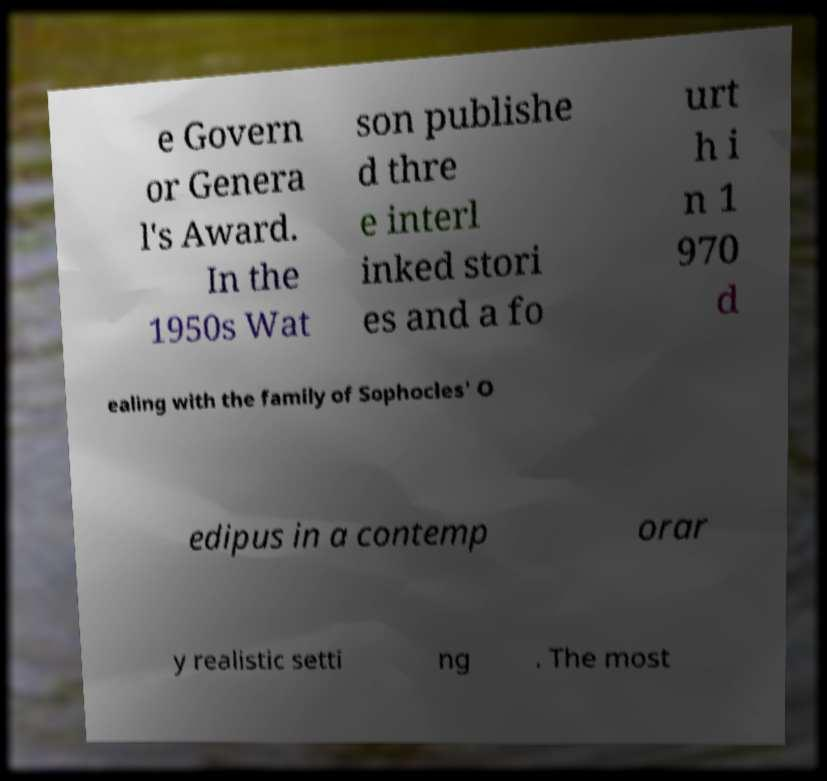Could you assist in decoding the text presented in this image and type it out clearly? e Govern or Genera l's Award. In the 1950s Wat son publishe d thre e interl inked stori es and a fo urt h i n 1 970 d ealing with the family of Sophocles' O edipus in a contemp orar y realistic setti ng . The most 